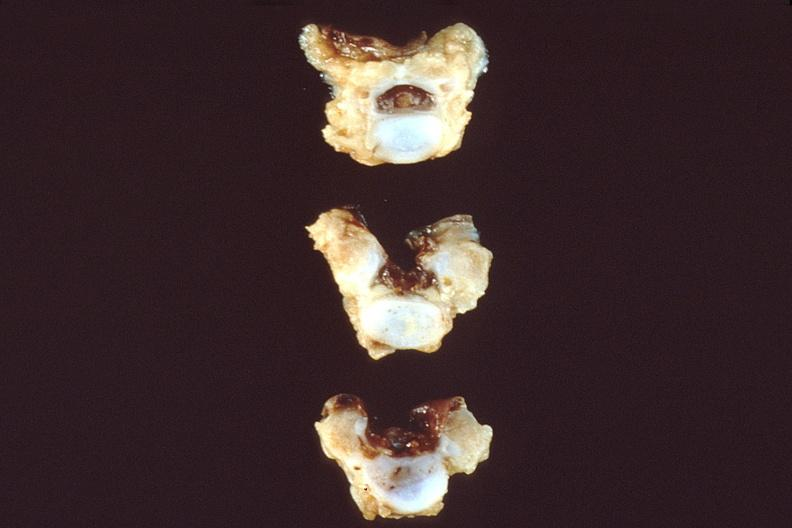s subcapsular hematoma present?
Answer the question using a single word or phrase. No 